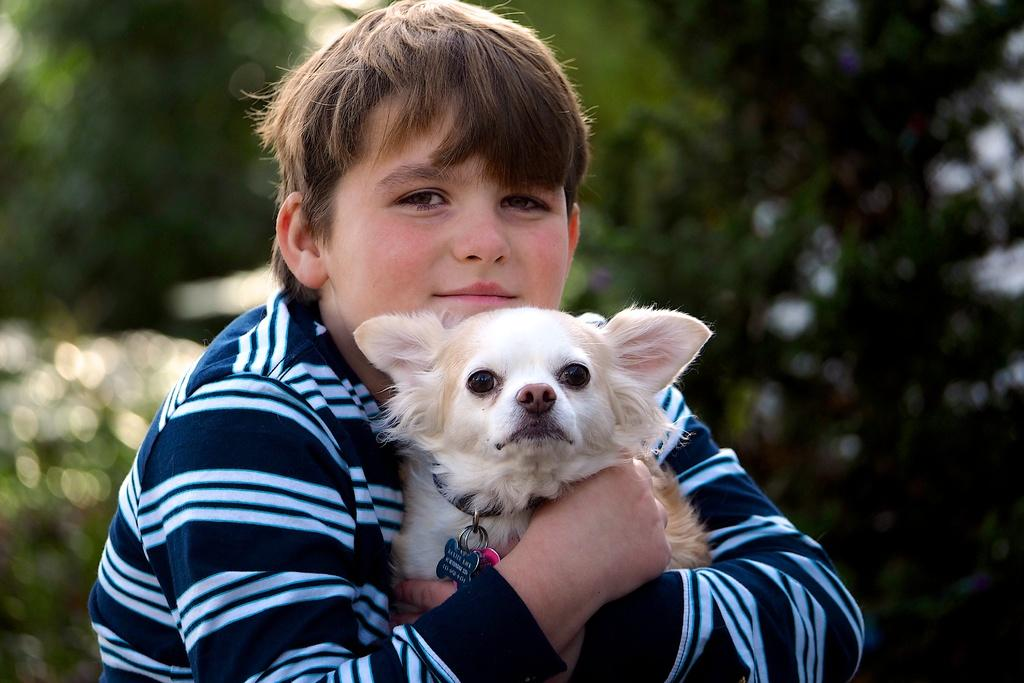What is the main subject of the image? There is a person in the image. What is the person wearing? The person is wearing a white and black colored dress. What is the person holding in the image? The person is holding a dog. Can you describe the dog's appearance? The dog is white and brown in color. What can be seen in the background of the image? The background of the image is green and blurry. What is the creator of the dog doing in the image? There is no reference to a creator in the image, as it features a person holding a dog. 